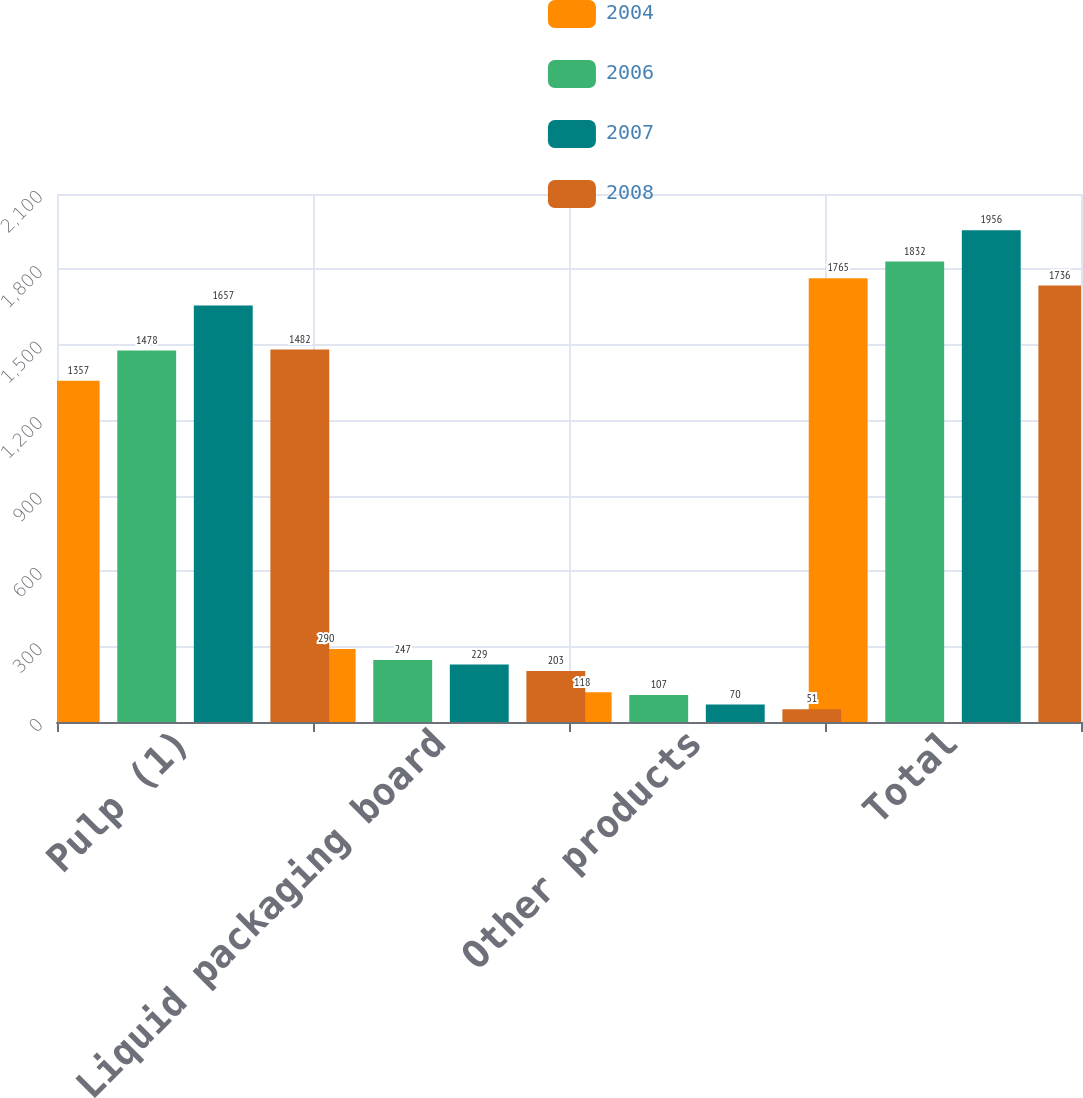<chart> <loc_0><loc_0><loc_500><loc_500><stacked_bar_chart><ecel><fcel>Pulp (1)<fcel>Liquid packaging board<fcel>Other products<fcel>Total<nl><fcel>2004<fcel>1357<fcel>290<fcel>118<fcel>1765<nl><fcel>2006<fcel>1478<fcel>247<fcel>107<fcel>1832<nl><fcel>2007<fcel>1657<fcel>229<fcel>70<fcel>1956<nl><fcel>2008<fcel>1482<fcel>203<fcel>51<fcel>1736<nl></chart> 